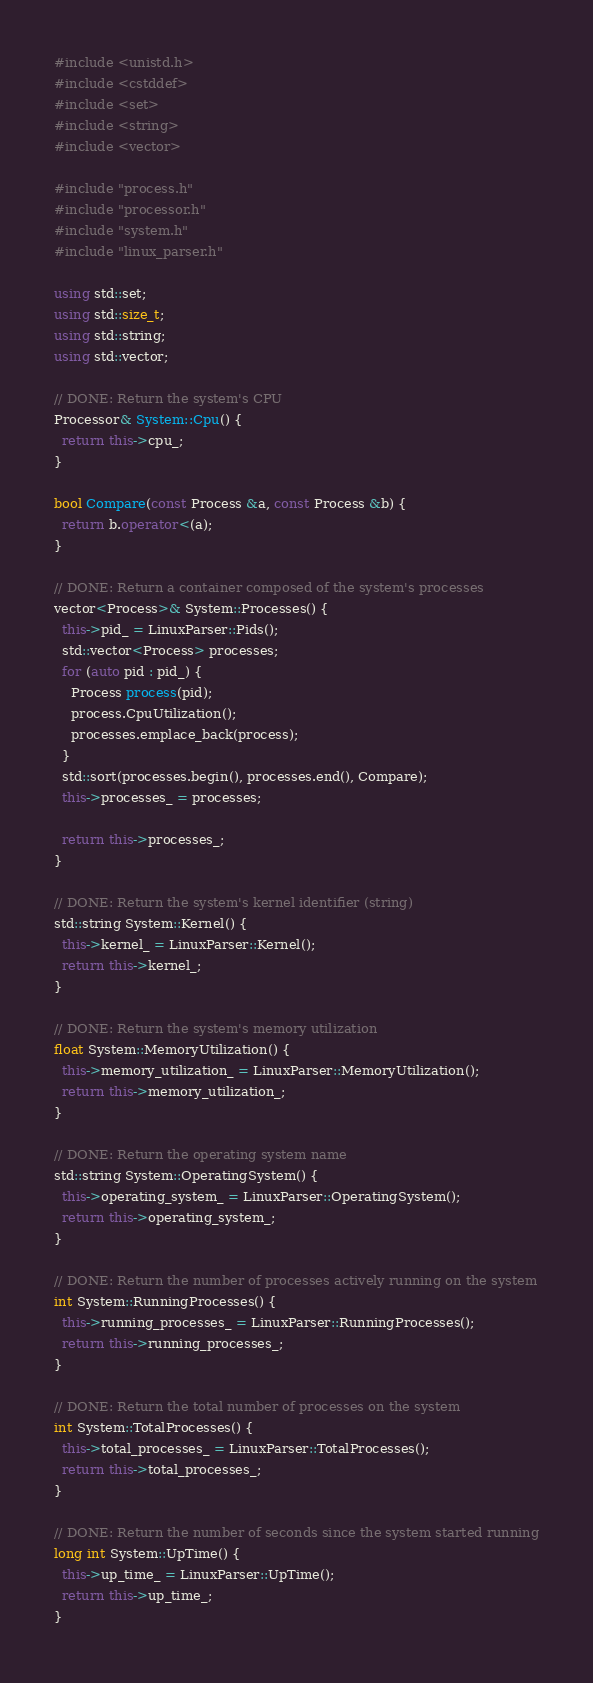<code> <loc_0><loc_0><loc_500><loc_500><_C++_>#include <unistd.h>
#include <cstddef>
#include <set>
#include <string>
#include <vector>

#include "process.h"
#include "processor.h"
#include "system.h"
#include "linux_parser.h"

using std::set;
using std::size_t;
using std::string;
using std::vector;

// DONE: Return the system's CPU
Processor& System::Cpu() {
  return this->cpu_;
}

bool Compare(const Process &a, const Process &b) {
  return b.operator<(a);
}

// DONE: Return a container composed of the system's processes
vector<Process>& System::Processes() {
  this->pid_ = LinuxParser::Pids();
  std::vector<Process> processes;
  for (auto pid : pid_) {
    Process process(pid);
    process.CpuUtilization();
    processes.emplace_back(process);
  }
  std::sort(processes.begin(), processes.end(), Compare);
  this->processes_ = processes;

  return this->processes_;
}

// DONE: Return the system's kernel identifier (string)
std::string System::Kernel() {
  this->kernel_ = LinuxParser::Kernel();
  return this->kernel_;
}

// DONE: Return the system's memory utilization
float System::MemoryUtilization() {
  this->memory_utilization_ = LinuxParser::MemoryUtilization();
  return this->memory_utilization_;
}

// DONE: Return the operating system name
std::string System::OperatingSystem() {
  this->operating_system_ = LinuxParser::OperatingSystem();
  return this->operating_system_;
}

// DONE: Return the number of processes actively running on the system
int System::RunningProcesses() {
  this->running_processes_ = LinuxParser::RunningProcesses();
  return this->running_processes_;
}

// DONE: Return the total number of processes on the system
int System::TotalProcesses() {
  this->total_processes_ = LinuxParser::TotalProcesses();
  return this->total_processes_;
}

// DONE: Return the number of seconds since the system started running
long int System::UpTime() {
  this->up_time_ = LinuxParser::UpTime();
  return this->up_time_;
}</code> 